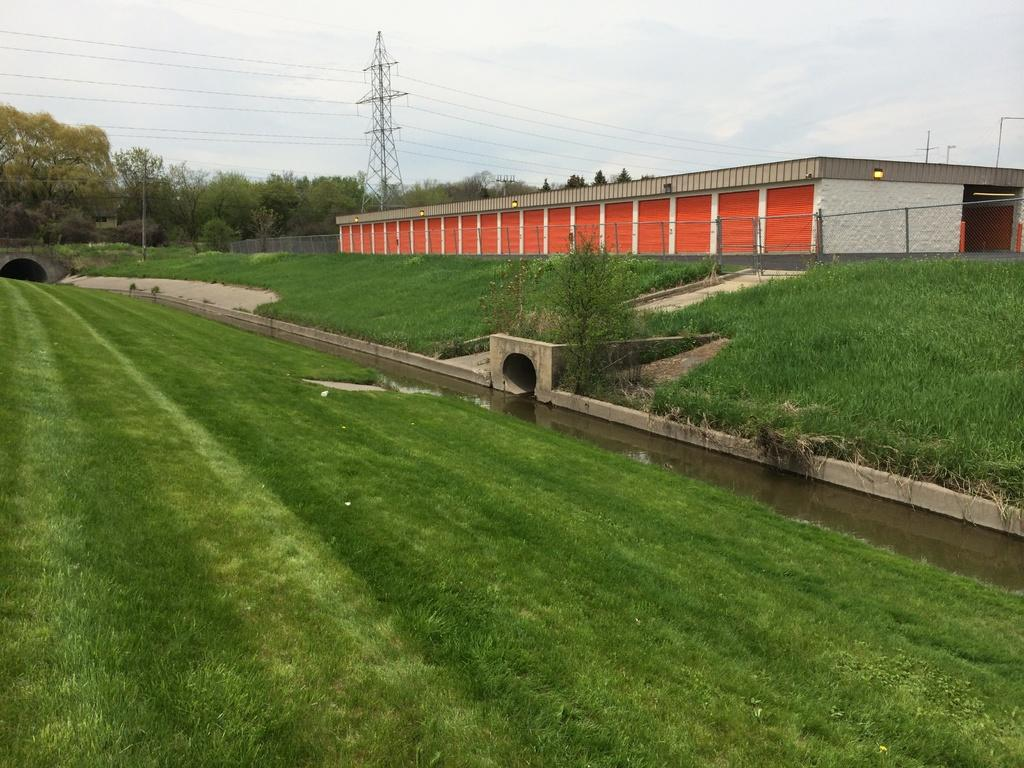What type of vegetation is present at the bottom of the image? There are plants and grass at the bottom of the image. What can be seen in the middle of the image? There are trees, a house, a fence, transmission poles, cables, and a bridge in the middle of the image. What is visible in the sky in the image? The sky is visible in the image, and clouds are present. How many chairs can be seen in the image? There are no chairs present in the image. What type of truck is driving across the bridge in the image? There is no truck present in the image; the bridge is empty. 